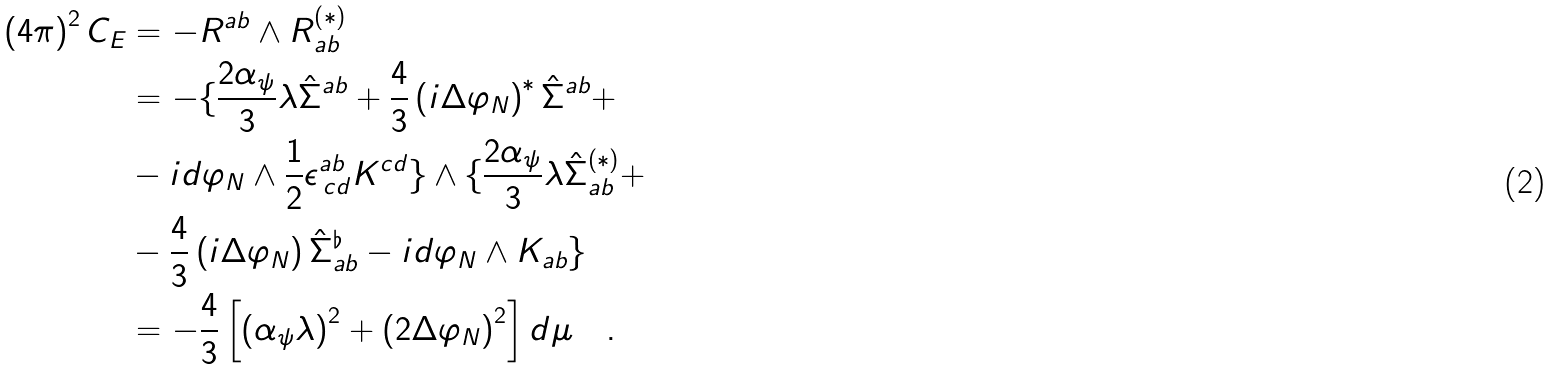<formula> <loc_0><loc_0><loc_500><loc_500>\left ( 4 \pi \right ) ^ { 2 } C _ { E } & = - R ^ { a b } \wedge R ^ { \left ( * \right ) } _ { a b } \\ & = - \{ \frac { 2 \alpha _ { \psi } } { 3 } \lambda \hat { \Sigma } ^ { a b } + \frac { 4 } { 3 } \left ( i \Delta \varphi _ { N } \right ) ^ { * } \hat { \Sigma } ^ { a b } + \\ & - i d \varphi _ { N } \wedge \frac { 1 } { 2 } \epsilon ^ { a b } _ { \, c d } K ^ { c d } \} \wedge \{ \frac { 2 \alpha _ { \psi } } { 3 } \lambda \hat { \Sigma } ^ { ( * ) } _ { a b } + \\ & - \frac { 4 } { 3 } \left ( i \Delta \varphi _ { N } \right ) \hat { \Sigma } ^ { \flat } _ { a b } - i d \varphi _ { N } \wedge K _ { a b } \} \\ & = - \frac { 4 } { 3 } \left [ \left ( \alpha _ { \psi } \lambda \right ) ^ { 2 } + \left ( 2 \Delta \varphi _ { N } \right ) ^ { 2 } \right ] d \mu \quad .</formula> 